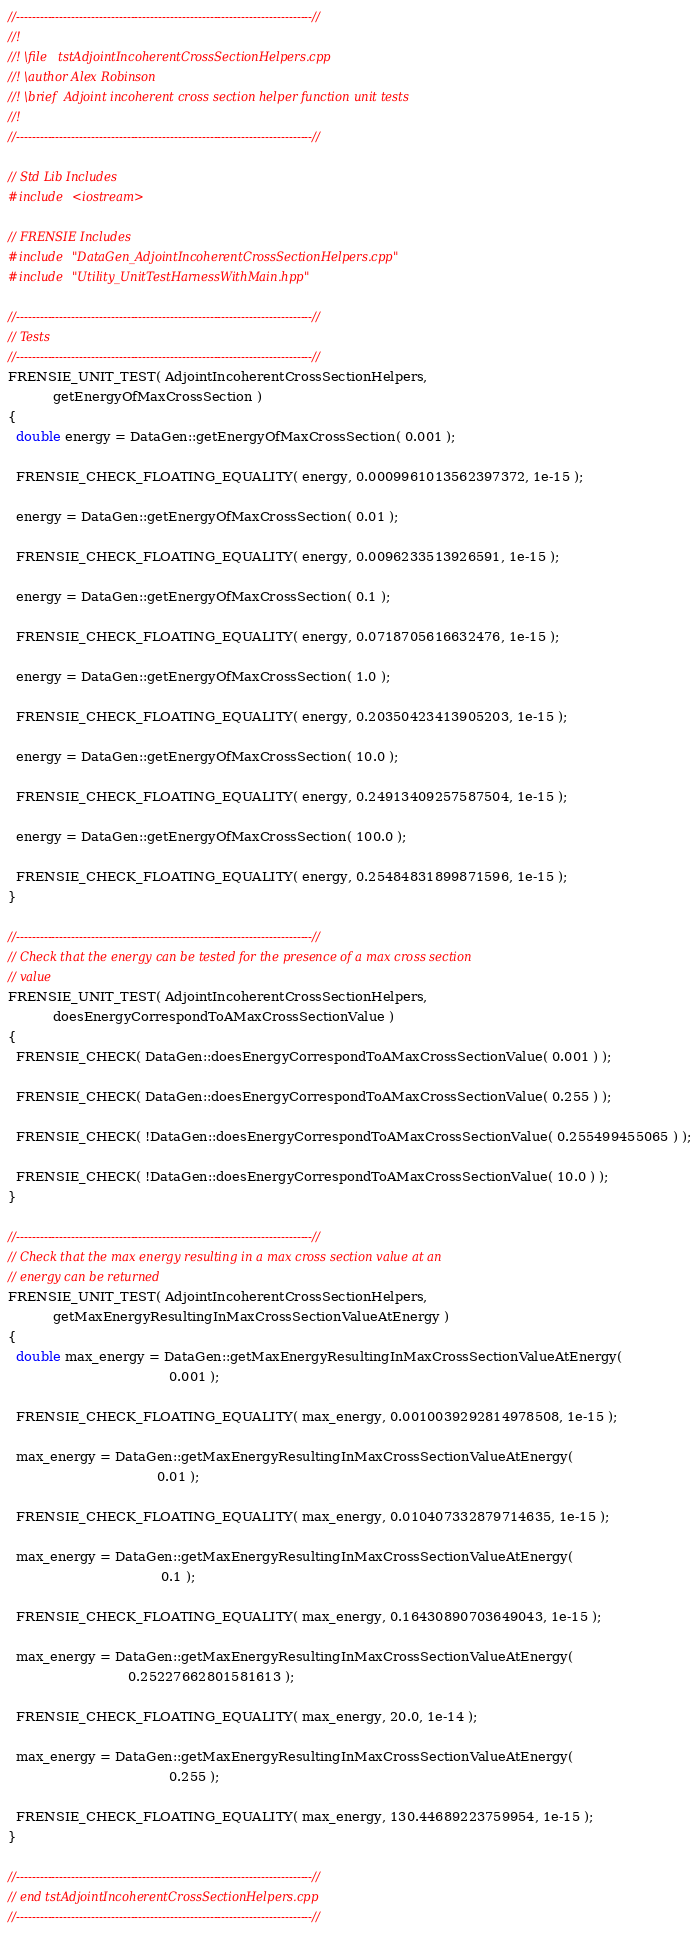<code> <loc_0><loc_0><loc_500><loc_500><_C++_>//---------------------------------------------------------------------------//
//!
//! \file   tstAdjointIncoherentCrossSectionHelpers.cpp
//! \author Alex Robinson
//! \brief  Adjoint incoherent cross section helper function unit tests
//!
//---------------------------------------------------------------------------//

// Std Lib Includes
#include <iostream>

// FRENSIE Includes
#include "DataGen_AdjointIncoherentCrossSectionHelpers.cpp"
#include "Utility_UnitTestHarnessWithMain.hpp"

//---------------------------------------------------------------------------//
// Tests
//---------------------------------------------------------------------------//
FRENSIE_UNIT_TEST( AdjointIncoherentCrossSectionHelpers,
		   getEnergyOfMaxCrossSection )
{
  double energy = DataGen::getEnergyOfMaxCrossSection( 0.001 );

  FRENSIE_CHECK_FLOATING_EQUALITY( energy, 0.0009961013562397372, 1e-15 );

  energy = DataGen::getEnergyOfMaxCrossSection( 0.01 );

  FRENSIE_CHECK_FLOATING_EQUALITY( energy, 0.0096233513926591, 1e-15 );

  energy = DataGen::getEnergyOfMaxCrossSection( 0.1 );

  FRENSIE_CHECK_FLOATING_EQUALITY( energy, 0.0718705616632476, 1e-15 );

  energy = DataGen::getEnergyOfMaxCrossSection( 1.0 );

  FRENSIE_CHECK_FLOATING_EQUALITY( energy, 0.20350423413905203, 1e-15 );

  energy = DataGen::getEnergyOfMaxCrossSection( 10.0 );

  FRENSIE_CHECK_FLOATING_EQUALITY( energy, 0.24913409257587504, 1e-15 );

  energy = DataGen::getEnergyOfMaxCrossSection( 100.0 );

  FRENSIE_CHECK_FLOATING_EQUALITY( energy, 0.25484831899871596, 1e-15 );
}

//---------------------------------------------------------------------------//
// Check that the energy can be tested for the presence of a max cross section
// value
FRENSIE_UNIT_TEST( AdjointIncoherentCrossSectionHelpers,
		   doesEnergyCorrespondToAMaxCrossSectionValue )
{
  FRENSIE_CHECK( DataGen::doesEnergyCorrespondToAMaxCrossSectionValue( 0.001 ) );

  FRENSIE_CHECK( DataGen::doesEnergyCorrespondToAMaxCrossSectionValue( 0.255 ) );

  FRENSIE_CHECK( !DataGen::doesEnergyCorrespondToAMaxCrossSectionValue( 0.255499455065 ) );

  FRENSIE_CHECK( !DataGen::doesEnergyCorrespondToAMaxCrossSectionValue( 10.0 ) );
}

//---------------------------------------------------------------------------//
// Check that the max energy resulting in a max cross section value at an
// energy can be returned
FRENSIE_UNIT_TEST( AdjointIncoherentCrossSectionHelpers,
		   getMaxEnergyResultingInMaxCrossSectionValueAtEnergy )
{
  double max_energy = DataGen::getMaxEnergyResultingInMaxCrossSectionValueAtEnergy(
								       0.001 );

  FRENSIE_CHECK_FLOATING_EQUALITY( max_energy, 0.0010039292814978508, 1e-15 );

  max_energy = DataGen::getMaxEnergyResultingInMaxCrossSectionValueAtEnergy(
									0.01 );

  FRENSIE_CHECK_FLOATING_EQUALITY( max_energy, 0.010407332879714635, 1e-15 );

  max_energy = DataGen::getMaxEnergyResultingInMaxCrossSectionValueAtEnergy(
									 0.1 );

  FRENSIE_CHECK_FLOATING_EQUALITY( max_energy, 0.16430890703649043, 1e-15 );

  max_energy = DataGen::getMaxEnergyResultingInMaxCrossSectionValueAtEnergy(
							 0.25227662801581613 );

  FRENSIE_CHECK_FLOATING_EQUALITY( max_energy, 20.0, 1e-14 );

  max_energy = DataGen::getMaxEnergyResultingInMaxCrossSectionValueAtEnergy(
								       0.255 );

  FRENSIE_CHECK_FLOATING_EQUALITY( max_energy, 130.44689223759954, 1e-15 );
}

//---------------------------------------------------------------------------//
// end tstAdjointIncoherentCrossSectionHelpers.cpp
//---------------------------------------------------------------------------//
</code> 